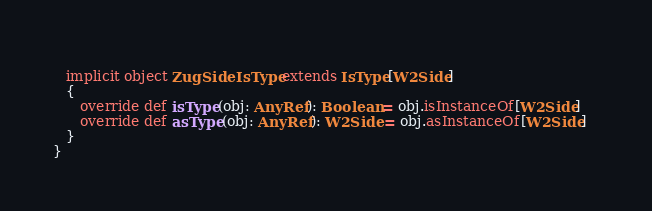<code> <loc_0><loc_0><loc_500><loc_500><_Scala_>   
   implicit object ZugSideIsType extends IsType[W2Side]
   {
      override def isType(obj: AnyRef): Boolean = obj.isInstanceOf[W2Side]
      override def asType(obj: AnyRef): W2Side = obj.asInstanceOf[W2Side]   
   }
}</code> 